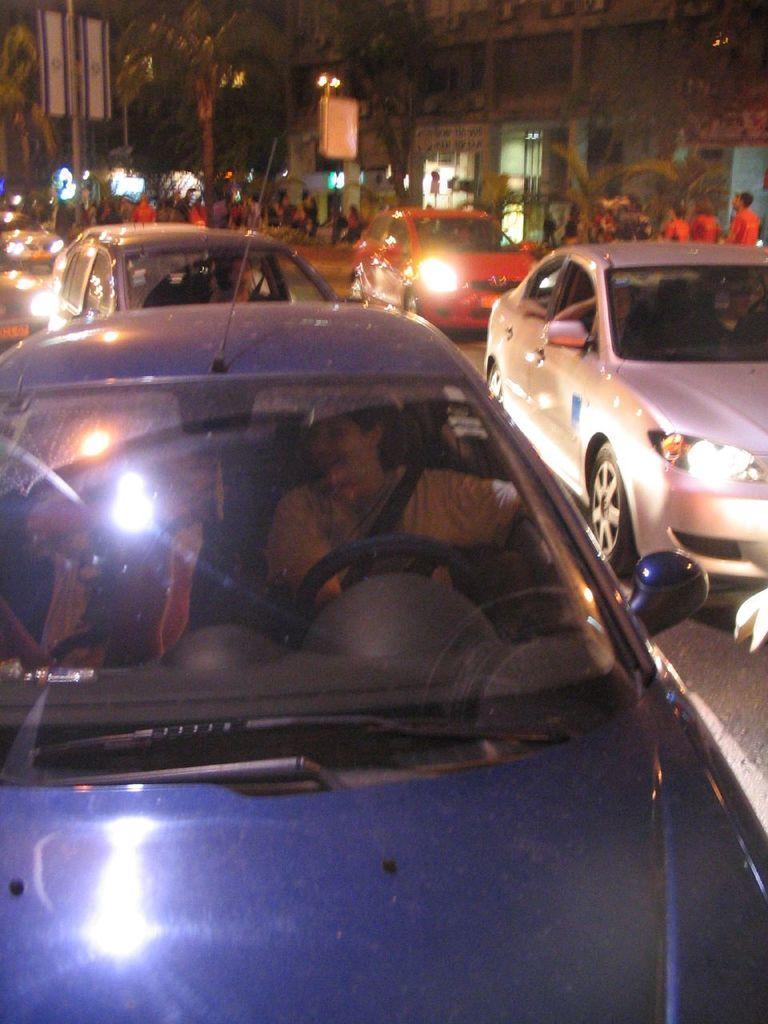Could you give a brief overview of what you see in this image? In this picture we can see the road on the road some vehicles are moving and side of the road people are walking at the background we can see the buildings trees electric poles. 